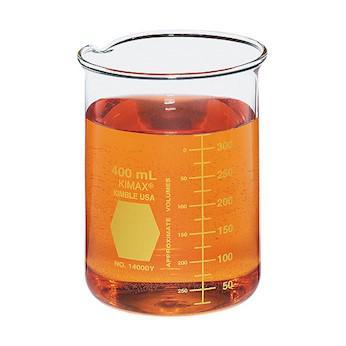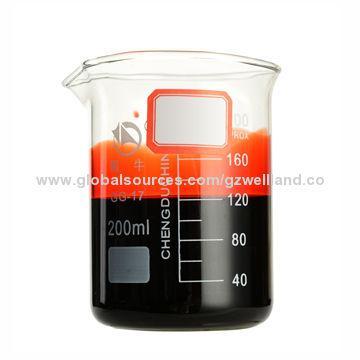The first image is the image on the left, the second image is the image on the right. Assess this claim about the two images: "The image on the right has at least 4 beakers.". Correct or not? Answer yes or no. No. The first image is the image on the left, the second image is the image on the right. Considering the images on both sides, is "There are less than nine containers." valid? Answer yes or no. Yes. 